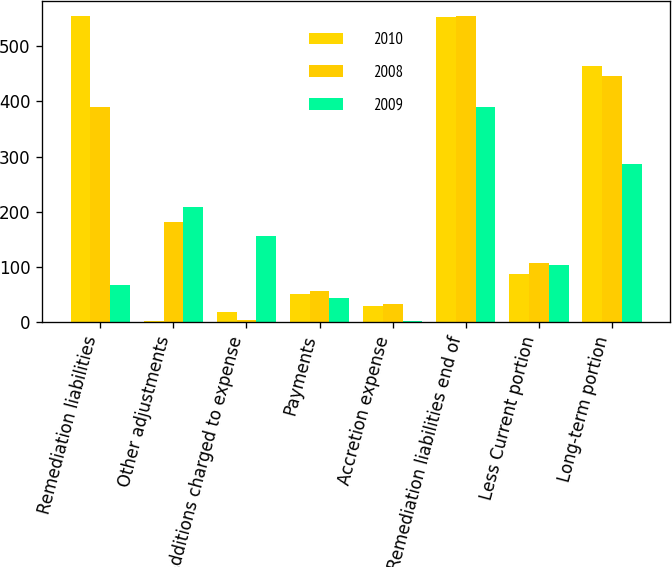Convert chart. <chart><loc_0><loc_0><loc_500><loc_500><stacked_bar_chart><ecel><fcel>Remediation liabilities<fcel>Other adjustments<fcel>Additions charged to expense<fcel>Payments<fcel>Accretion expense<fcel>Remediation liabilities end of<fcel>Less Current portion<fcel>Long-term portion<nl><fcel>2010<fcel>554.1<fcel>1.5<fcel>17.9<fcel>50.5<fcel>29.1<fcel>552.1<fcel>88.1<fcel>464<nl><fcel>2008<fcel>389.9<fcel>181.9<fcel>4.9<fcel>56.2<fcel>33.6<fcel>554.1<fcel>107.9<fcel>446.2<nl><fcel>2009<fcel>67.5<fcel>208.1<fcel>155.9<fcel>43.3<fcel>1.7<fcel>389.9<fcel>102.8<fcel>287.1<nl></chart> 